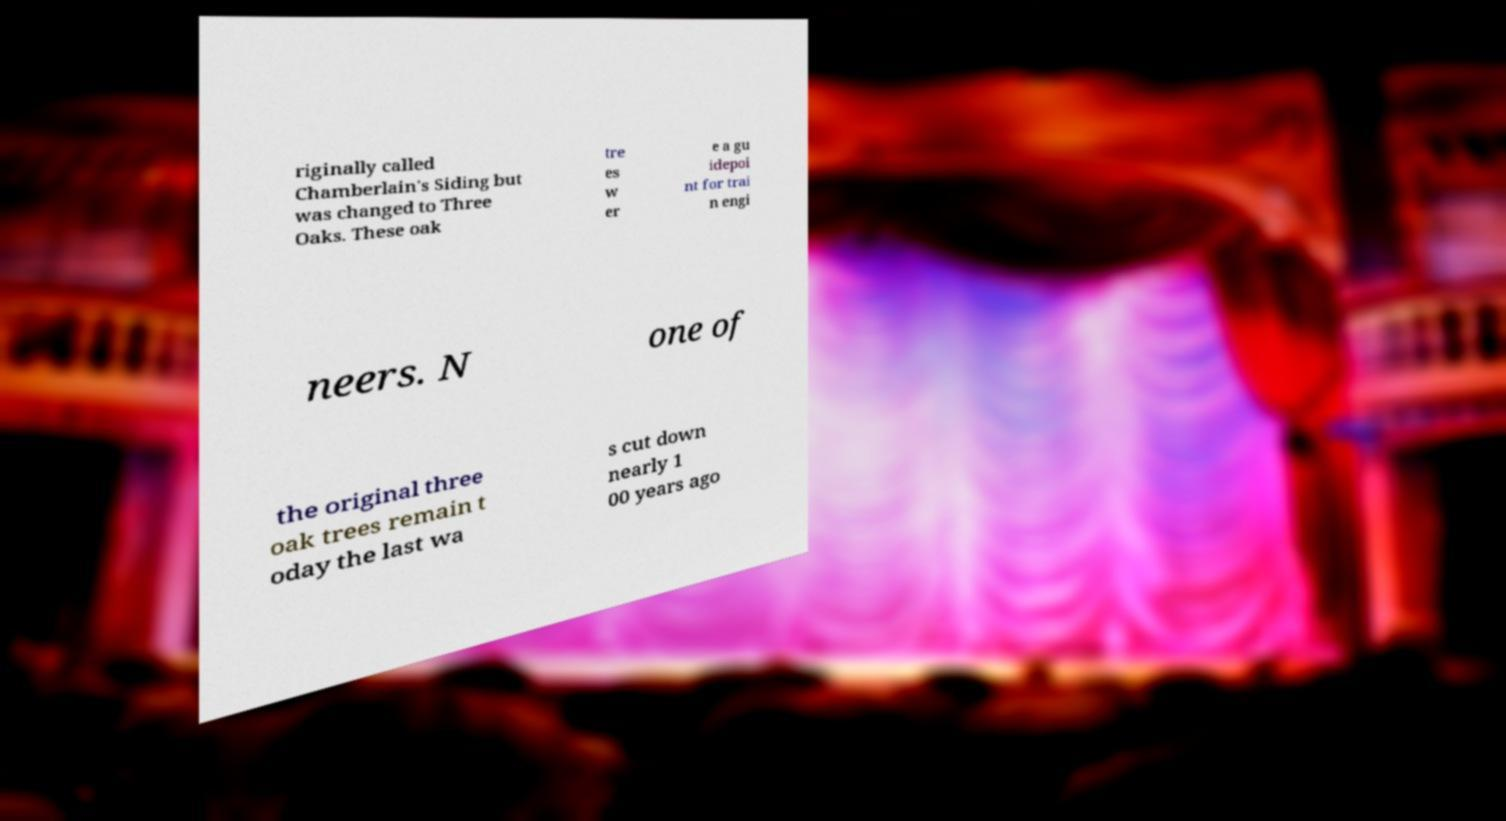Could you assist in decoding the text presented in this image and type it out clearly? riginally called Chamberlain's Siding but was changed to Three Oaks. These oak tre es w er e a gu idepoi nt for trai n engi neers. N one of the original three oak trees remain t oday the last wa s cut down nearly 1 00 years ago 